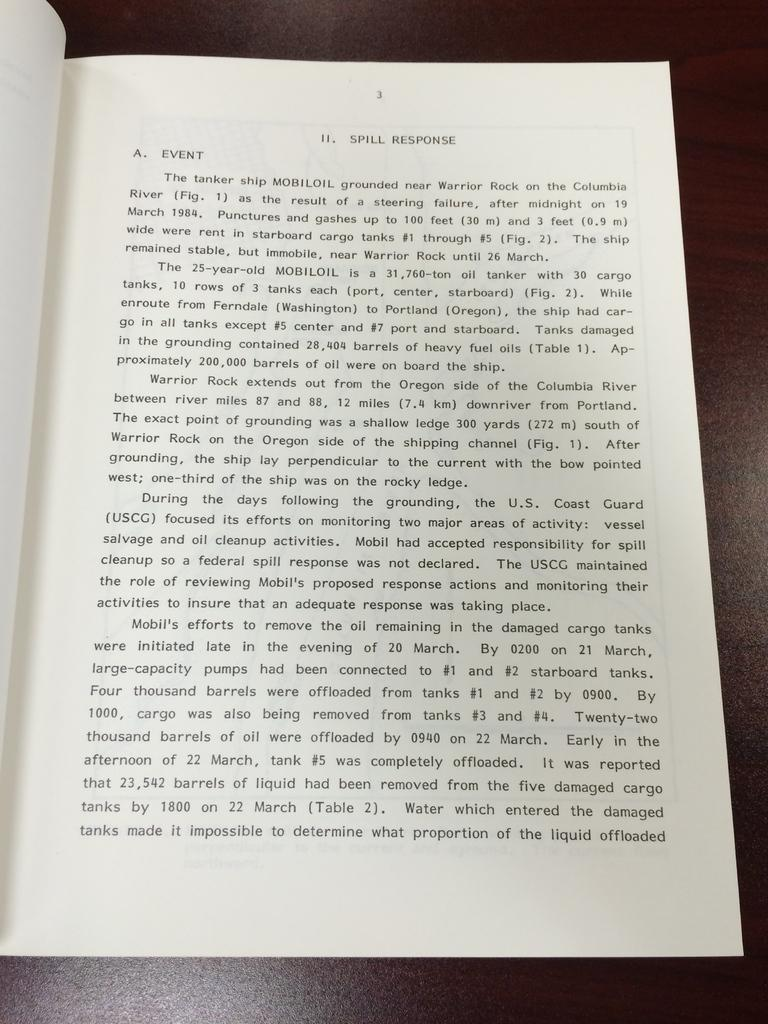<image>
Present a compact description of the photo's key features. A book is open to page 3 that's titled Spill Response. 